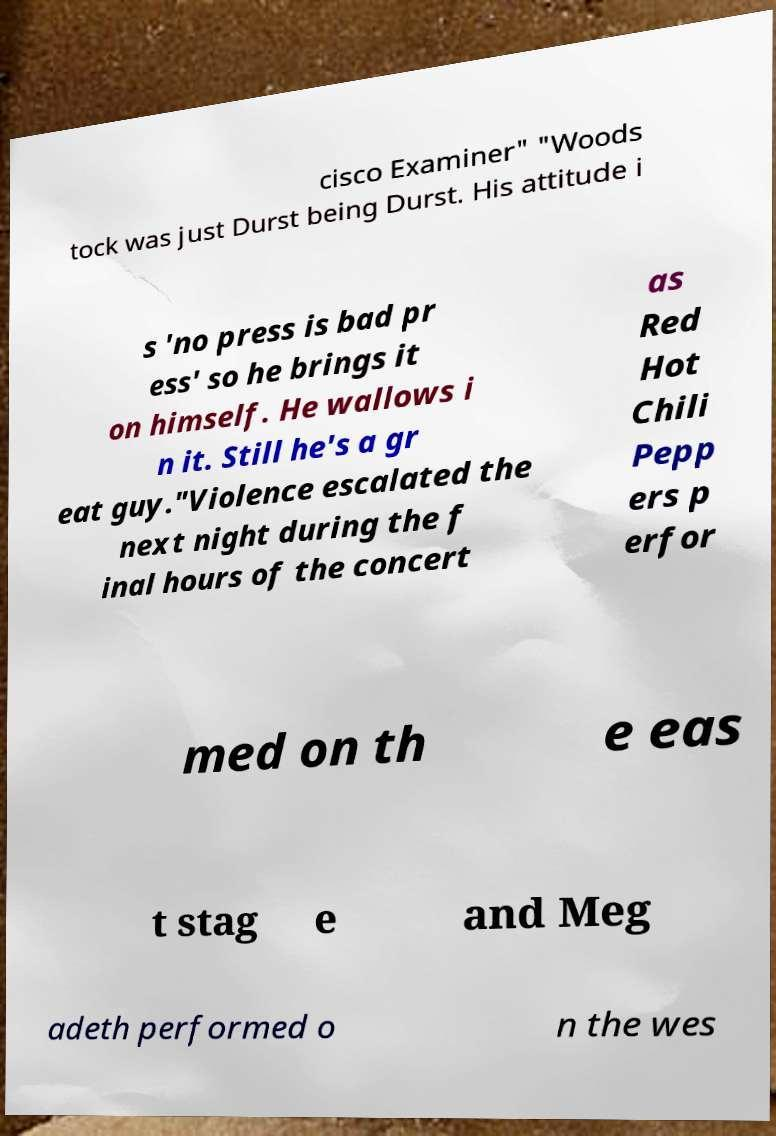Can you accurately transcribe the text from the provided image for me? cisco Examiner" "Woods tock was just Durst being Durst. His attitude i s 'no press is bad pr ess' so he brings it on himself. He wallows i n it. Still he's a gr eat guy."Violence escalated the next night during the f inal hours of the concert as Red Hot Chili Pepp ers p erfor med on th e eas t stag e and Meg adeth performed o n the wes 